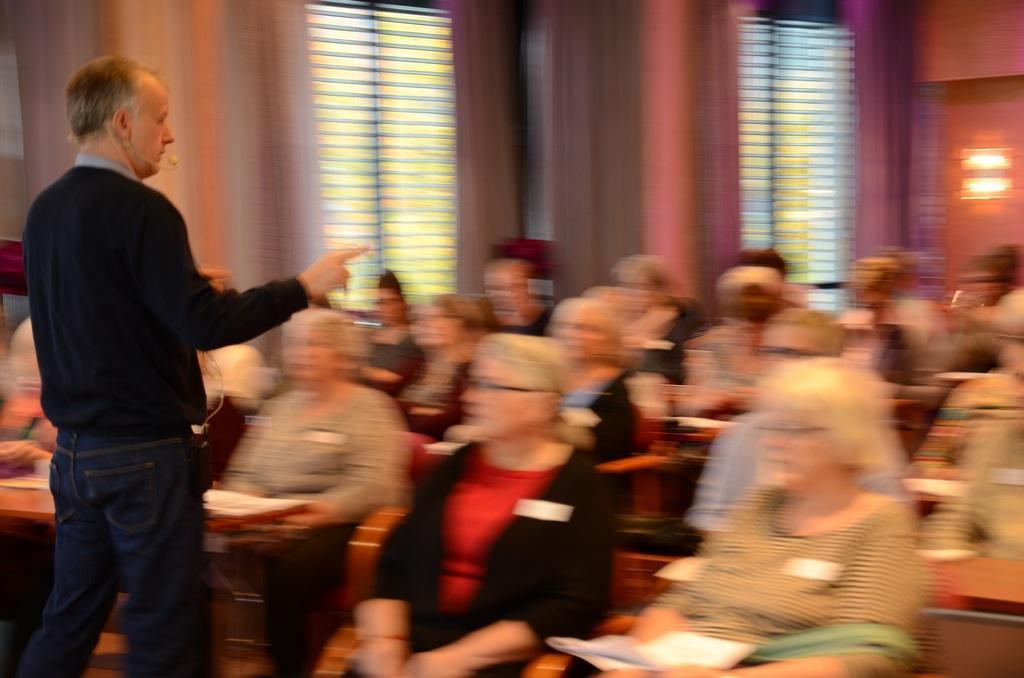How would you summarize this image in a sentence or two? On the left side of the image there is a man standing on the floor. On the left side of the image we can see many persons sitting on the chairs. In the background we can see walls, curtains, windows and light. 